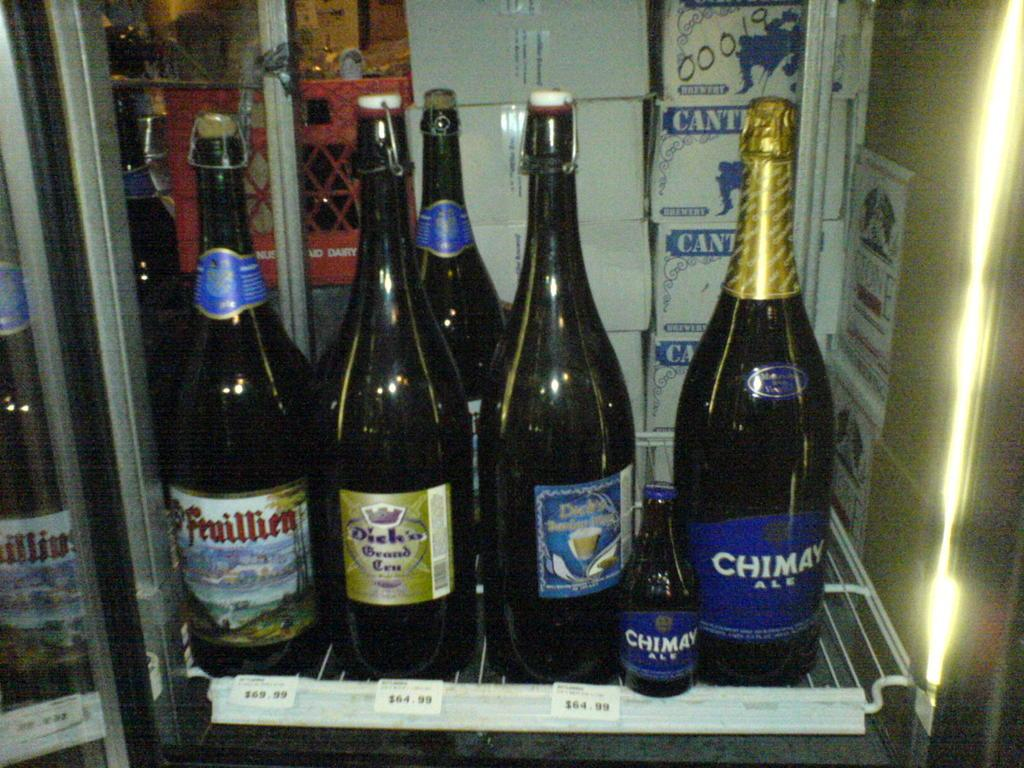Provide a one-sentence caption for the provided image. Alcohol in a chilled case at the store that includes Feuillien brand alcohol. 